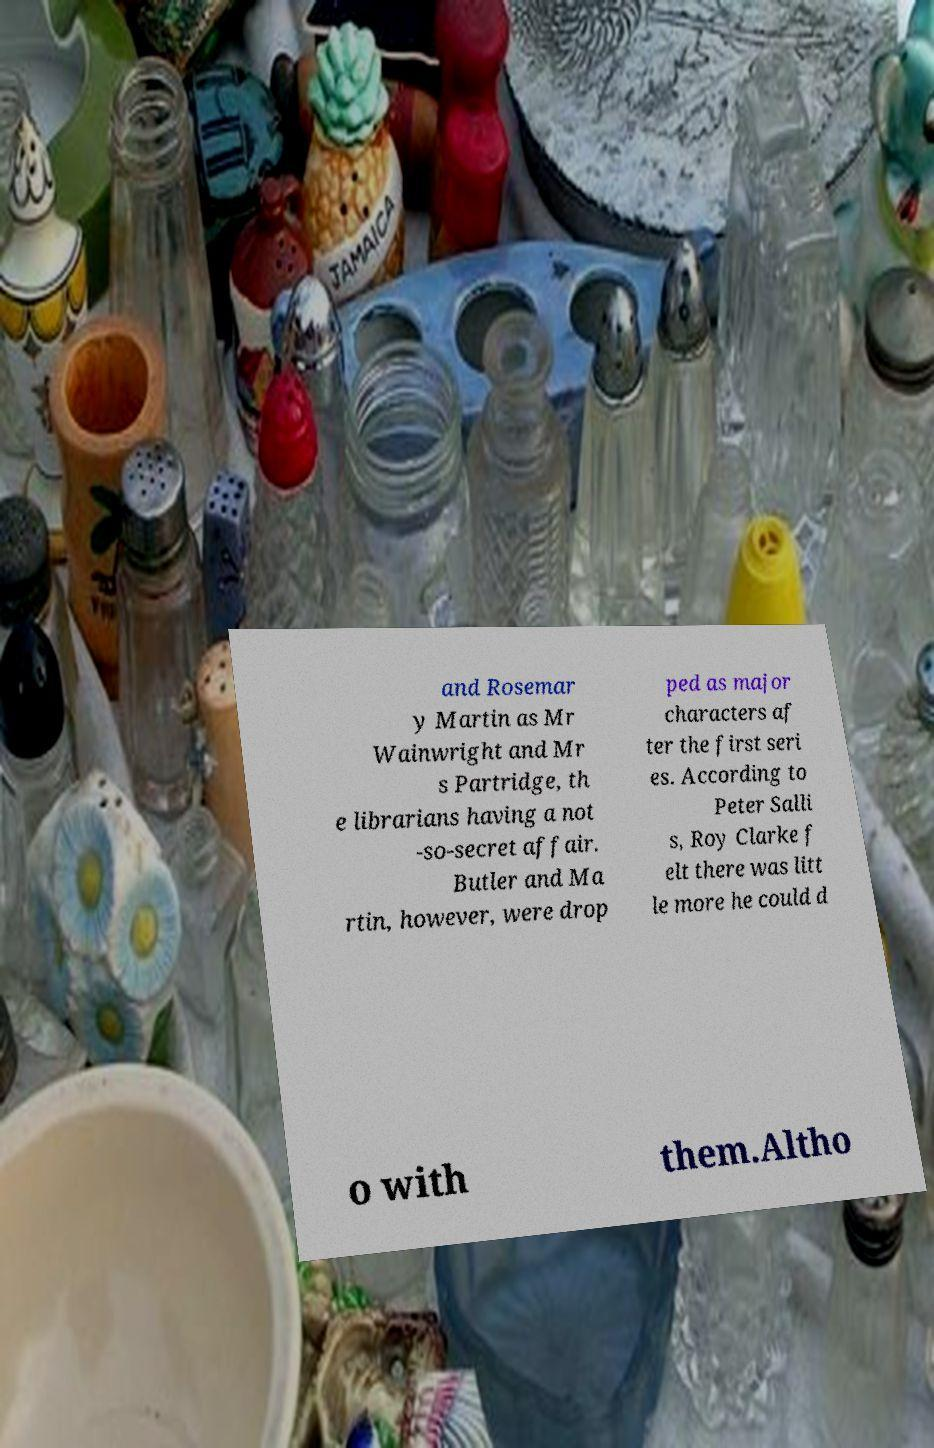Can you accurately transcribe the text from the provided image for me? and Rosemar y Martin as Mr Wainwright and Mr s Partridge, th e librarians having a not -so-secret affair. Butler and Ma rtin, however, were drop ped as major characters af ter the first seri es. According to Peter Salli s, Roy Clarke f elt there was litt le more he could d o with them.Altho 